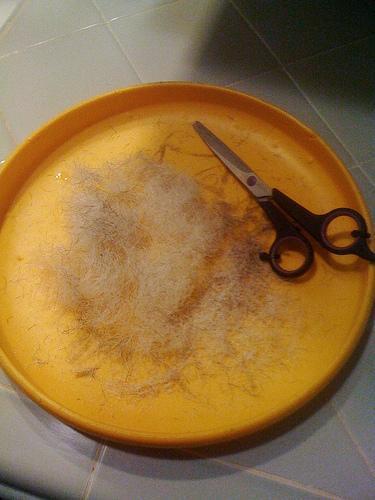How many pairs of scissors are in the photo?
Give a very brief answer. 1. 